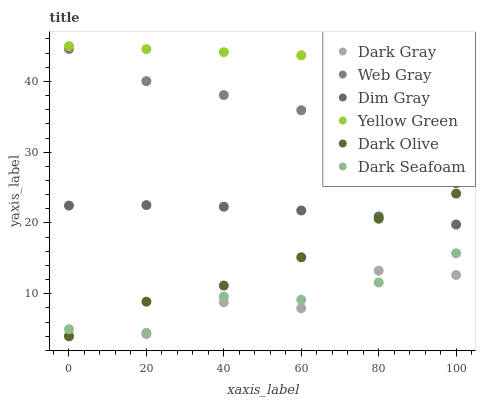Does Dark Gray have the minimum area under the curve?
Answer yes or no. Yes. Does Yellow Green have the maximum area under the curve?
Answer yes or no. Yes. Does Dark Olive have the minimum area under the curve?
Answer yes or no. No. Does Dark Olive have the maximum area under the curve?
Answer yes or no. No. Is Yellow Green the smoothest?
Answer yes or no. Yes. Is Dark Gray the roughest?
Answer yes or no. Yes. Is Dark Olive the smoothest?
Answer yes or no. No. Is Dark Olive the roughest?
Answer yes or no. No. Does Dark Olive have the lowest value?
Answer yes or no. Yes. Does Yellow Green have the lowest value?
Answer yes or no. No. Does Yellow Green have the highest value?
Answer yes or no. Yes. Does Dark Olive have the highest value?
Answer yes or no. No. Is Dark Gray less than Dim Gray?
Answer yes or no. Yes. Is Web Gray greater than Dark Seafoam?
Answer yes or no. Yes. Does Dark Olive intersect Dark Seafoam?
Answer yes or no. Yes. Is Dark Olive less than Dark Seafoam?
Answer yes or no. No. Is Dark Olive greater than Dark Seafoam?
Answer yes or no. No. Does Dark Gray intersect Dim Gray?
Answer yes or no. No. 